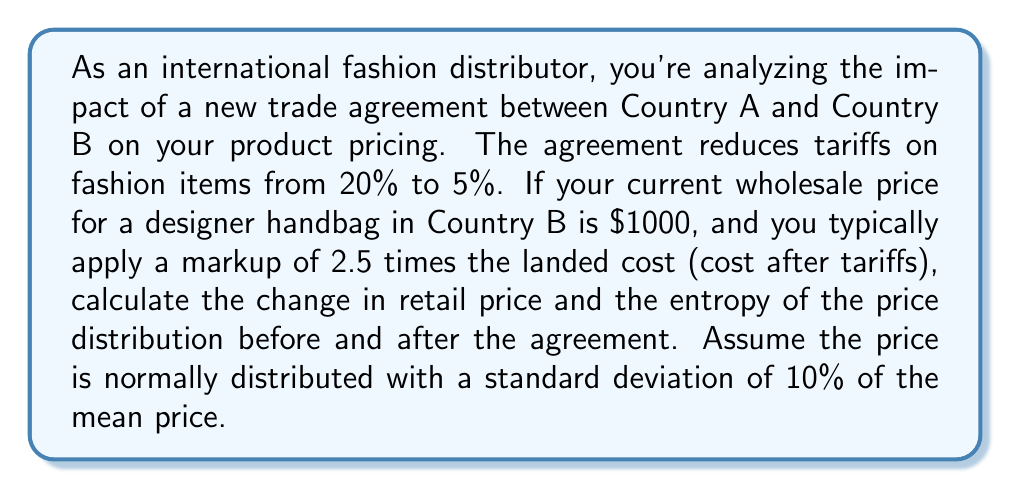Show me your answer to this math problem. Let's break this down step-by-step:

1. Calculate the landed cost before and after the trade agreement:
   - Before: $1000 * (1 + 0.20) = $1200
   - After: $1000 * (1 + 0.05) = $1050

2. Calculate the retail price before and after the trade agreement:
   - Before: $1200 * 2.5 = $3000
   - After: $1050 * 2.5 = $2625

3. The change in retail price:
   $3000 - $2625 = $375 decrease

4. To calculate the entropy, we need to use the formula for the entropy of a normal distribution:
   $$H = \frac{1}{2}\ln(2\pi e\sigma^2)$$
   where $\sigma$ is the standard deviation.

5. Calculate the standard deviation for each case:
   - Before: $\sigma_1 = 0.10 * 3000 = 300$
   - After: $\sigma_2 = 0.10 * 2625 = 262.5$

6. Calculate the entropy for each case:
   - Before: $$H_1 = \frac{1}{2}\ln(2\pi e(300)^2) \approx 6.3969$$
   - After: $$H_2 = \frac{1}{2}\ln(2\pi e(262.5)^2) \approx 6.2388$$

7. Calculate the change in entropy:
   $6.2388 - 6.3969 = -0.1581$

The negative change in entropy indicates a decrease in price uncertainty or variability after the trade agreement.
Answer: The retail price decreases by $375. The entropy of the price distribution decreases by approximately 0.1581 bits. 